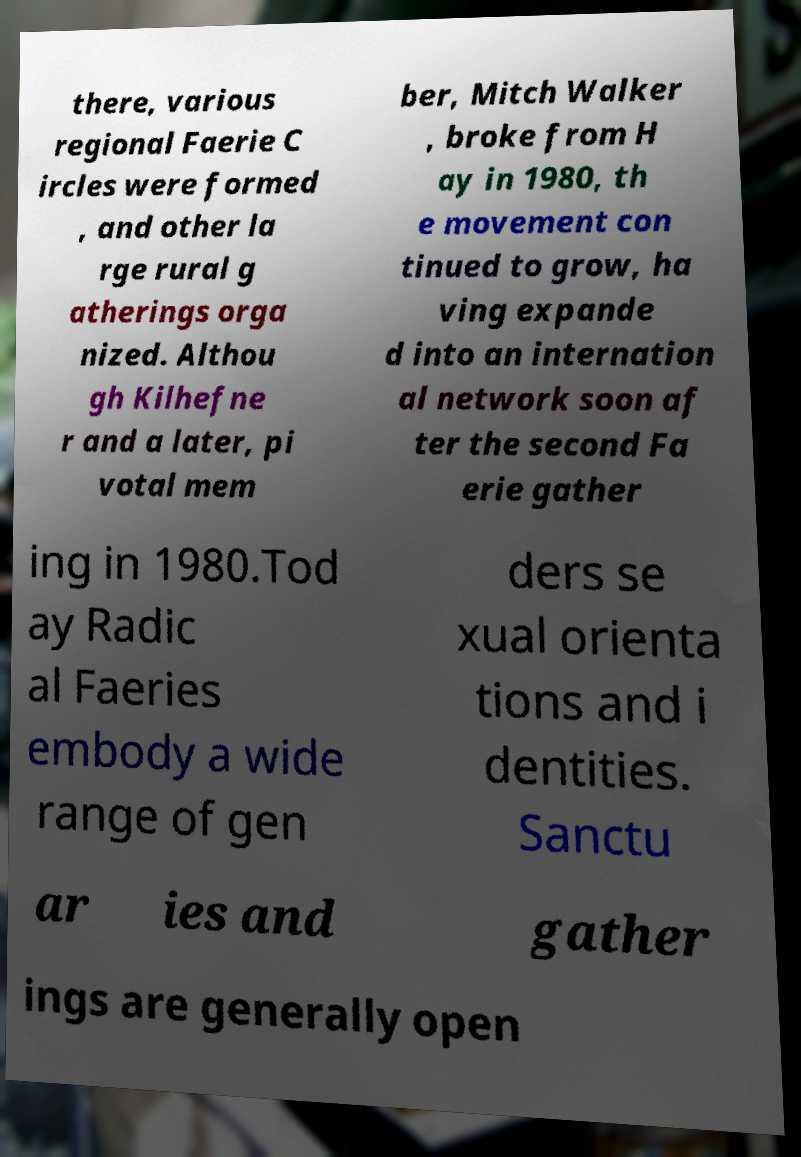For documentation purposes, I need the text within this image transcribed. Could you provide that? there, various regional Faerie C ircles were formed , and other la rge rural g atherings orga nized. Althou gh Kilhefne r and a later, pi votal mem ber, Mitch Walker , broke from H ay in 1980, th e movement con tinued to grow, ha ving expande d into an internation al network soon af ter the second Fa erie gather ing in 1980.Tod ay Radic al Faeries embody a wide range of gen ders se xual orienta tions and i dentities. Sanctu ar ies and gather ings are generally open 